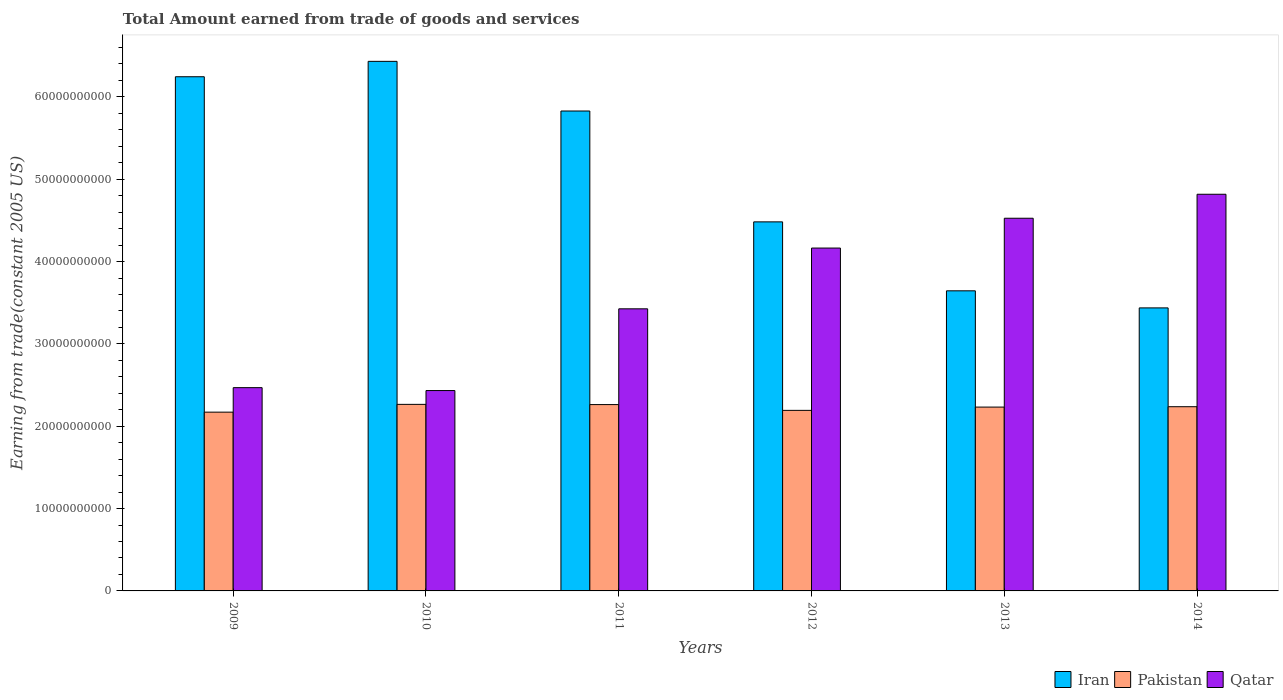How many different coloured bars are there?
Give a very brief answer. 3. Are the number of bars per tick equal to the number of legend labels?
Your response must be concise. Yes. What is the label of the 1st group of bars from the left?
Provide a succinct answer. 2009. In how many cases, is the number of bars for a given year not equal to the number of legend labels?
Offer a terse response. 0. What is the total amount earned by trading goods and services in Pakistan in 2010?
Give a very brief answer. 2.27e+1. Across all years, what is the maximum total amount earned by trading goods and services in Qatar?
Give a very brief answer. 4.82e+1. Across all years, what is the minimum total amount earned by trading goods and services in Iran?
Keep it short and to the point. 3.44e+1. What is the total total amount earned by trading goods and services in Qatar in the graph?
Ensure brevity in your answer.  2.18e+11. What is the difference between the total amount earned by trading goods and services in Qatar in 2012 and that in 2014?
Give a very brief answer. -6.53e+09. What is the difference between the total amount earned by trading goods and services in Iran in 2011 and the total amount earned by trading goods and services in Pakistan in 2009?
Make the answer very short. 3.66e+1. What is the average total amount earned by trading goods and services in Pakistan per year?
Offer a terse response. 2.23e+1. In the year 2014, what is the difference between the total amount earned by trading goods and services in Pakistan and total amount earned by trading goods and services in Qatar?
Provide a short and direct response. -2.58e+1. What is the ratio of the total amount earned by trading goods and services in Qatar in 2009 to that in 2013?
Offer a very short reply. 0.55. Is the difference between the total amount earned by trading goods and services in Pakistan in 2010 and 2012 greater than the difference between the total amount earned by trading goods and services in Qatar in 2010 and 2012?
Your answer should be compact. Yes. What is the difference between the highest and the second highest total amount earned by trading goods and services in Qatar?
Keep it short and to the point. 2.91e+09. What is the difference between the highest and the lowest total amount earned by trading goods and services in Pakistan?
Keep it short and to the point. 9.44e+08. Is the sum of the total amount earned by trading goods and services in Qatar in 2010 and 2014 greater than the maximum total amount earned by trading goods and services in Iran across all years?
Your response must be concise. Yes. What does the 2nd bar from the left in 2010 represents?
Ensure brevity in your answer.  Pakistan. What does the 2nd bar from the right in 2010 represents?
Provide a succinct answer. Pakistan. Are all the bars in the graph horizontal?
Give a very brief answer. No. How many years are there in the graph?
Provide a short and direct response. 6. What is the difference between two consecutive major ticks on the Y-axis?
Ensure brevity in your answer.  1.00e+1. Are the values on the major ticks of Y-axis written in scientific E-notation?
Your answer should be very brief. No. Does the graph contain grids?
Your answer should be very brief. No. How are the legend labels stacked?
Offer a very short reply. Horizontal. What is the title of the graph?
Your answer should be compact. Total Amount earned from trade of goods and services. Does "Panama" appear as one of the legend labels in the graph?
Provide a short and direct response. No. What is the label or title of the Y-axis?
Your answer should be very brief. Earning from trade(constant 2005 US). What is the Earning from trade(constant 2005 US) in Iran in 2009?
Give a very brief answer. 6.24e+1. What is the Earning from trade(constant 2005 US) of Pakistan in 2009?
Provide a short and direct response. 2.17e+1. What is the Earning from trade(constant 2005 US) of Qatar in 2009?
Provide a succinct answer. 2.47e+1. What is the Earning from trade(constant 2005 US) in Iran in 2010?
Your answer should be very brief. 6.43e+1. What is the Earning from trade(constant 2005 US) in Pakistan in 2010?
Give a very brief answer. 2.27e+1. What is the Earning from trade(constant 2005 US) in Qatar in 2010?
Your answer should be very brief. 2.43e+1. What is the Earning from trade(constant 2005 US) in Iran in 2011?
Make the answer very short. 5.83e+1. What is the Earning from trade(constant 2005 US) of Pakistan in 2011?
Your answer should be compact. 2.26e+1. What is the Earning from trade(constant 2005 US) of Qatar in 2011?
Give a very brief answer. 3.43e+1. What is the Earning from trade(constant 2005 US) in Iran in 2012?
Offer a terse response. 4.48e+1. What is the Earning from trade(constant 2005 US) of Pakistan in 2012?
Your answer should be very brief. 2.19e+1. What is the Earning from trade(constant 2005 US) of Qatar in 2012?
Give a very brief answer. 4.16e+1. What is the Earning from trade(constant 2005 US) in Iran in 2013?
Your answer should be very brief. 3.64e+1. What is the Earning from trade(constant 2005 US) in Pakistan in 2013?
Provide a succinct answer. 2.23e+1. What is the Earning from trade(constant 2005 US) of Qatar in 2013?
Give a very brief answer. 4.53e+1. What is the Earning from trade(constant 2005 US) of Iran in 2014?
Your answer should be very brief. 3.44e+1. What is the Earning from trade(constant 2005 US) of Pakistan in 2014?
Offer a terse response. 2.24e+1. What is the Earning from trade(constant 2005 US) in Qatar in 2014?
Your answer should be very brief. 4.82e+1. Across all years, what is the maximum Earning from trade(constant 2005 US) of Iran?
Ensure brevity in your answer.  6.43e+1. Across all years, what is the maximum Earning from trade(constant 2005 US) of Pakistan?
Offer a terse response. 2.27e+1. Across all years, what is the maximum Earning from trade(constant 2005 US) in Qatar?
Provide a short and direct response. 4.82e+1. Across all years, what is the minimum Earning from trade(constant 2005 US) of Iran?
Offer a terse response. 3.44e+1. Across all years, what is the minimum Earning from trade(constant 2005 US) of Pakistan?
Keep it short and to the point. 2.17e+1. Across all years, what is the minimum Earning from trade(constant 2005 US) in Qatar?
Give a very brief answer. 2.43e+1. What is the total Earning from trade(constant 2005 US) in Iran in the graph?
Your answer should be very brief. 3.01e+11. What is the total Earning from trade(constant 2005 US) in Pakistan in the graph?
Ensure brevity in your answer.  1.34e+11. What is the total Earning from trade(constant 2005 US) in Qatar in the graph?
Your answer should be very brief. 2.18e+11. What is the difference between the Earning from trade(constant 2005 US) of Iran in 2009 and that in 2010?
Your answer should be compact. -1.87e+09. What is the difference between the Earning from trade(constant 2005 US) of Pakistan in 2009 and that in 2010?
Make the answer very short. -9.44e+08. What is the difference between the Earning from trade(constant 2005 US) in Qatar in 2009 and that in 2010?
Your answer should be compact. 3.52e+08. What is the difference between the Earning from trade(constant 2005 US) of Iran in 2009 and that in 2011?
Give a very brief answer. 4.16e+09. What is the difference between the Earning from trade(constant 2005 US) of Pakistan in 2009 and that in 2011?
Your answer should be very brief. -9.17e+08. What is the difference between the Earning from trade(constant 2005 US) in Qatar in 2009 and that in 2011?
Offer a very short reply. -9.57e+09. What is the difference between the Earning from trade(constant 2005 US) of Iran in 2009 and that in 2012?
Give a very brief answer. 1.76e+1. What is the difference between the Earning from trade(constant 2005 US) in Pakistan in 2009 and that in 2012?
Provide a succinct answer. -2.16e+08. What is the difference between the Earning from trade(constant 2005 US) of Qatar in 2009 and that in 2012?
Keep it short and to the point. -1.70e+1. What is the difference between the Earning from trade(constant 2005 US) of Iran in 2009 and that in 2013?
Ensure brevity in your answer.  2.60e+1. What is the difference between the Earning from trade(constant 2005 US) of Pakistan in 2009 and that in 2013?
Offer a very short reply. -6.13e+08. What is the difference between the Earning from trade(constant 2005 US) of Qatar in 2009 and that in 2013?
Provide a succinct answer. -2.06e+1. What is the difference between the Earning from trade(constant 2005 US) of Iran in 2009 and that in 2014?
Offer a very short reply. 2.81e+1. What is the difference between the Earning from trade(constant 2005 US) of Pakistan in 2009 and that in 2014?
Offer a terse response. -6.59e+08. What is the difference between the Earning from trade(constant 2005 US) in Qatar in 2009 and that in 2014?
Your response must be concise. -2.35e+1. What is the difference between the Earning from trade(constant 2005 US) of Iran in 2010 and that in 2011?
Your response must be concise. 6.03e+09. What is the difference between the Earning from trade(constant 2005 US) of Pakistan in 2010 and that in 2011?
Offer a very short reply. 2.70e+07. What is the difference between the Earning from trade(constant 2005 US) of Qatar in 2010 and that in 2011?
Your answer should be compact. -9.93e+09. What is the difference between the Earning from trade(constant 2005 US) in Iran in 2010 and that in 2012?
Give a very brief answer. 1.95e+1. What is the difference between the Earning from trade(constant 2005 US) in Pakistan in 2010 and that in 2012?
Make the answer very short. 7.28e+08. What is the difference between the Earning from trade(constant 2005 US) of Qatar in 2010 and that in 2012?
Provide a succinct answer. -1.73e+1. What is the difference between the Earning from trade(constant 2005 US) in Iran in 2010 and that in 2013?
Ensure brevity in your answer.  2.79e+1. What is the difference between the Earning from trade(constant 2005 US) of Pakistan in 2010 and that in 2013?
Give a very brief answer. 3.31e+08. What is the difference between the Earning from trade(constant 2005 US) in Qatar in 2010 and that in 2013?
Keep it short and to the point. -2.09e+1. What is the difference between the Earning from trade(constant 2005 US) of Iran in 2010 and that in 2014?
Make the answer very short. 2.99e+1. What is the difference between the Earning from trade(constant 2005 US) in Pakistan in 2010 and that in 2014?
Provide a short and direct response. 2.85e+08. What is the difference between the Earning from trade(constant 2005 US) of Qatar in 2010 and that in 2014?
Give a very brief answer. -2.38e+1. What is the difference between the Earning from trade(constant 2005 US) of Iran in 2011 and that in 2012?
Offer a terse response. 1.35e+1. What is the difference between the Earning from trade(constant 2005 US) of Pakistan in 2011 and that in 2012?
Provide a short and direct response. 7.01e+08. What is the difference between the Earning from trade(constant 2005 US) in Qatar in 2011 and that in 2012?
Keep it short and to the point. -7.38e+09. What is the difference between the Earning from trade(constant 2005 US) of Iran in 2011 and that in 2013?
Ensure brevity in your answer.  2.18e+1. What is the difference between the Earning from trade(constant 2005 US) in Pakistan in 2011 and that in 2013?
Make the answer very short. 3.04e+08. What is the difference between the Earning from trade(constant 2005 US) in Qatar in 2011 and that in 2013?
Offer a very short reply. -1.10e+1. What is the difference between the Earning from trade(constant 2005 US) of Iran in 2011 and that in 2014?
Offer a terse response. 2.39e+1. What is the difference between the Earning from trade(constant 2005 US) of Pakistan in 2011 and that in 2014?
Provide a succinct answer. 2.58e+08. What is the difference between the Earning from trade(constant 2005 US) of Qatar in 2011 and that in 2014?
Your answer should be very brief. -1.39e+1. What is the difference between the Earning from trade(constant 2005 US) in Iran in 2012 and that in 2013?
Provide a succinct answer. 8.37e+09. What is the difference between the Earning from trade(constant 2005 US) of Pakistan in 2012 and that in 2013?
Offer a very short reply. -3.97e+08. What is the difference between the Earning from trade(constant 2005 US) in Qatar in 2012 and that in 2013?
Offer a terse response. -3.62e+09. What is the difference between the Earning from trade(constant 2005 US) in Iran in 2012 and that in 2014?
Offer a terse response. 1.04e+1. What is the difference between the Earning from trade(constant 2005 US) in Pakistan in 2012 and that in 2014?
Make the answer very short. -4.43e+08. What is the difference between the Earning from trade(constant 2005 US) in Qatar in 2012 and that in 2014?
Offer a very short reply. -6.53e+09. What is the difference between the Earning from trade(constant 2005 US) in Iran in 2013 and that in 2014?
Ensure brevity in your answer.  2.07e+09. What is the difference between the Earning from trade(constant 2005 US) of Pakistan in 2013 and that in 2014?
Provide a succinct answer. -4.60e+07. What is the difference between the Earning from trade(constant 2005 US) in Qatar in 2013 and that in 2014?
Offer a terse response. -2.91e+09. What is the difference between the Earning from trade(constant 2005 US) of Iran in 2009 and the Earning from trade(constant 2005 US) of Pakistan in 2010?
Your answer should be compact. 3.98e+1. What is the difference between the Earning from trade(constant 2005 US) of Iran in 2009 and the Earning from trade(constant 2005 US) of Qatar in 2010?
Offer a terse response. 3.81e+1. What is the difference between the Earning from trade(constant 2005 US) of Pakistan in 2009 and the Earning from trade(constant 2005 US) of Qatar in 2010?
Provide a succinct answer. -2.62e+09. What is the difference between the Earning from trade(constant 2005 US) of Iran in 2009 and the Earning from trade(constant 2005 US) of Pakistan in 2011?
Your answer should be compact. 3.98e+1. What is the difference between the Earning from trade(constant 2005 US) of Iran in 2009 and the Earning from trade(constant 2005 US) of Qatar in 2011?
Give a very brief answer. 2.82e+1. What is the difference between the Earning from trade(constant 2005 US) of Pakistan in 2009 and the Earning from trade(constant 2005 US) of Qatar in 2011?
Give a very brief answer. -1.25e+1. What is the difference between the Earning from trade(constant 2005 US) of Iran in 2009 and the Earning from trade(constant 2005 US) of Pakistan in 2012?
Your answer should be compact. 4.05e+1. What is the difference between the Earning from trade(constant 2005 US) of Iran in 2009 and the Earning from trade(constant 2005 US) of Qatar in 2012?
Ensure brevity in your answer.  2.08e+1. What is the difference between the Earning from trade(constant 2005 US) of Pakistan in 2009 and the Earning from trade(constant 2005 US) of Qatar in 2012?
Provide a succinct answer. -1.99e+1. What is the difference between the Earning from trade(constant 2005 US) of Iran in 2009 and the Earning from trade(constant 2005 US) of Pakistan in 2013?
Keep it short and to the point. 4.01e+1. What is the difference between the Earning from trade(constant 2005 US) of Iran in 2009 and the Earning from trade(constant 2005 US) of Qatar in 2013?
Ensure brevity in your answer.  1.72e+1. What is the difference between the Earning from trade(constant 2005 US) in Pakistan in 2009 and the Earning from trade(constant 2005 US) in Qatar in 2013?
Provide a short and direct response. -2.36e+1. What is the difference between the Earning from trade(constant 2005 US) in Iran in 2009 and the Earning from trade(constant 2005 US) in Pakistan in 2014?
Your answer should be very brief. 4.01e+1. What is the difference between the Earning from trade(constant 2005 US) in Iran in 2009 and the Earning from trade(constant 2005 US) in Qatar in 2014?
Give a very brief answer. 1.43e+1. What is the difference between the Earning from trade(constant 2005 US) of Pakistan in 2009 and the Earning from trade(constant 2005 US) of Qatar in 2014?
Your answer should be compact. -2.65e+1. What is the difference between the Earning from trade(constant 2005 US) of Iran in 2010 and the Earning from trade(constant 2005 US) of Pakistan in 2011?
Provide a short and direct response. 4.17e+1. What is the difference between the Earning from trade(constant 2005 US) of Iran in 2010 and the Earning from trade(constant 2005 US) of Qatar in 2011?
Make the answer very short. 3.01e+1. What is the difference between the Earning from trade(constant 2005 US) in Pakistan in 2010 and the Earning from trade(constant 2005 US) in Qatar in 2011?
Give a very brief answer. -1.16e+1. What is the difference between the Earning from trade(constant 2005 US) in Iran in 2010 and the Earning from trade(constant 2005 US) in Pakistan in 2012?
Give a very brief answer. 4.24e+1. What is the difference between the Earning from trade(constant 2005 US) of Iran in 2010 and the Earning from trade(constant 2005 US) of Qatar in 2012?
Your answer should be very brief. 2.27e+1. What is the difference between the Earning from trade(constant 2005 US) in Pakistan in 2010 and the Earning from trade(constant 2005 US) in Qatar in 2012?
Provide a succinct answer. -1.90e+1. What is the difference between the Earning from trade(constant 2005 US) in Iran in 2010 and the Earning from trade(constant 2005 US) in Pakistan in 2013?
Your answer should be compact. 4.20e+1. What is the difference between the Earning from trade(constant 2005 US) of Iran in 2010 and the Earning from trade(constant 2005 US) of Qatar in 2013?
Provide a succinct answer. 1.91e+1. What is the difference between the Earning from trade(constant 2005 US) of Pakistan in 2010 and the Earning from trade(constant 2005 US) of Qatar in 2013?
Offer a very short reply. -2.26e+1. What is the difference between the Earning from trade(constant 2005 US) in Iran in 2010 and the Earning from trade(constant 2005 US) in Pakistan in 2014?
Give a very brief answer. 4.19e+1. What is the difference between the Earning from trade(constant 2005 US) of Iran in 2010 and the Earning from trade(constant 2005 US) of Qatar in 2014?
Your answer should be compact. 1.61e+1. What is the difference between the Earning from trade(constant 2005 US) of Pakistan in 2010 and the Earning from trade(constant 2005 US) of Qatar in 2014?
Provide a short and direct response. -2.55e+1. What is the difference between the Earning from trade(constant 2005 US) in Iran in 2011 and the Earning from trade(constant 2005 US) in Pakistan in 2012?
Provide a succinct answer. 3.64e+1. What is the difference between the Earning from trade(constant 2005 US) of Iran in 2011 and the Earning from trade(constant 2005 US) of Qatar in 2012?
Give a very brief answer. 1.66e+1. What is the difference between the Earning from trade(constant 2005 US) of Pakistan in 2011 and the Earning from trade(constant 2005 US) of Qatar in 2012?
Give a very brief answer. -1.90e+1. What is the difference between the Earning from trade(constant 2005 US) in Iran in 2011 and the Earning from trade(constant 2005 US) in Pakistan in 2013?
Your answer should be compact. 3.60e+1. What is the difference between the Earning from trade(constant 2005 US) of Iran in 2011 and the Earning from trade(constant 2005 US) of Qatar in 2013?
Make the answer very short. 1.30e+1. What is the difference between the Earning from trade(constant 2005 US) of Pakistan in 2011 and the Earning from trade(constant 2005 US) of Qatar in 2013?
Your response must be concise. -2.26e+1. What is the difference between the Earning from trade(constant 2005 US) in Iran in 2011 and the Earning from trade(constant 2005 US) in Pakistan in 2014?
Your answer should be very brief. 3.59e+1. What is the difference between the Earning from trade(constant 2005 US) in Iran in 2011 and the Earning from trade(constant 2005 US) in Qatar in 2014?
Give a very brief answer. 1.01e+1. What is the difference between the Earning from trade(constant 2005 US) of Pakistan in 2011 and the Earning from trade(constant 2005 US) of Qatar in 2014?
Your answer should be compact. -2.55e+1. What is the difference between the Earning from trade(constant 2005 US) of Iran in 2012 and the Earning from trade(constant 2005 US) of Pakistan in 2013?
Provide a succinct answer. 2.25e+1. What is the difference between the Earning from trade(constant 2005 US) of Iran in 2012 and the Earning from trade(constant 2005 US) of Qatar in 2013?
Provide a succinct answer. -4.41e+08. What is the difference between the Earning from trade(constant 2005 US) in Pakistan in 2012 and the Earning from trade(constant 2005 US) in Qatar in 2013?
Give a very brief answer. -2.33e+1. What is the difference between the Earning from trade(constant 2005 US) in Iran in 2012 and the Earning from trade(constant 2005 US) in Pakistan in 2014?
Provide a succinct answer. 2.25e+1. What is the difference between the Earning from trade(constant 2005 US) of Iran in 2012 and the Earning from trade(constant 2005 US) of Qatar in 2014?
Offer a very short reply. -3.35e+09. What is the difference between the Earning from trade(constant 2005 US) in Pakistan in 2012 and the Earning from trade(constant 2005 US) in Qatar in 2014?
Offer a very short reply. -2.62e+1. What is the difference between the Earning from trade(constant 2005 US) in Iran in 2013 and the Earning from trade(constant 2005 US) in Pakistan in 2014?
Offer a terse response. 1.41e+1. What is the difference between the Earning from trade(constant 2005 US) in Iran in 2013 and the Earning from trade(constant 2005 US) in Qatar in 2014?
Make the answer very short. -1.17e+1. What is the difference between the Earning from trade(constant 2005 US) of Pakistan in 2013 and the Earning from trade(constant 2005 US) of Qatar in 2014?
Provide a short and direct response. -2.58e+1. What is the average Earning from trade(constant 2005 US) of Iran per year?
Offer a very short reply. 5.01e+1. What is the average Earning from trade(constant 2005 US) in Pakistan per year?
Provide a short and direct response. 2.23e+1. What is the average Earning from trade(constant 2005 US) of Qatar per year?
Give a very brief answer. 3.64e+1. In the year 2009, what is the difference between the Earning from trade(constant 2005 US) in Iran and Earning from trade(constant 2005 US) in Pakistan?
Provide a short and direct response. 4.07e+1. In the year 2009, what is the difference between the Earning from trade(constant 2005 US) in Iran and Earning from trade(constant 2005 US) in Qatar?
Your answer should be compact. 3.78e+1. In the year 2009, what is the difference between the Earning from trade(constant 2005 US) in Pakistan and Earning from trade(constant 2005 US) in Qatar?
Give a very brief answer. -2.97e+09. In the year 2010, what is the difference between the Earning from trade(constant 2005 US) of Iran and Earning from trade(constant 2005 US) of Pakistan?
Provide a short and direct response. 4.17e+1. In the year 2010, what is the difference between the Earning from trade(constant 2005 US) in Iran and Earning from trade(constant 2005 US) in Qatar?
Offer a terse response. 4.00e+1. In the year 2010, what is the difference between the Earning from trade(constant 2005 US) in Pakistan and Earning from trade(constant 2005 US) in Qatar?
Your answer should be very brief. -1.68e+09. In the year 2011, what is the difference between the Earning from trade(constant 2005 US) in Iran and Earning from trade(constant 2005 US) in Pakistan?
Your answer should be compact. 3.57e+1. In the year 2011, what is the difference between the Earning from trade(constant 2005 US) in Iran and Earning from trade(constant 2005 US) in Qatar?
Offer a very short reply. 2.40e+1. In the year 2011, what is the difference between the Earning from trade(constant 2005 US) in Pakistan and Earning from trade(constant 2005 US) in Qatar?
Provide a succinct answer. -1.16e+1. In the year 2012, what is the difference between the Earning from trade(constant 2005 US) in Iran and Earning from trade(constant 2005 US) in Pakistan?
Keep it short and to the point. 2.29e+1. In the year 2012, what is the difference between the Earning from trade(constant 2005 US) of Iran and Earning from trade(constant 2005 US) of Qatar?
Offer a very short reply. 3.18e+09. In the year 2012, what is the difference between the Earning from trade(constant 2005 US) in Pakistan and Earning from trade(constant 2005 US) in Qatar?
Offer a very short reply. -1.97e+1. In the year 2013, what is the difference between the Earning from trade(constant 2005 US) in Iran and Earning from trade(constant 2005 US) in Pakistan?
Your answer should be compact. 1.41e+1. In the year 2013, what is the difference between the Earning from trade(constant 2005 US) in Iran and Earning from trade(constant 2005 US) in Qatar?
Offer a very short reply. -8.82e+09. In the year 2013, what is the difference between the Earning from trade(constant 2005 US) of Pakistan and Earning from trade(constant 2005 US) of Qatar?
Offer a terse response. -2.29e+1. In the year 2014, what is the difference between the Earning from trade(constant 2005 US) of Iran and Earning from trade(constant 2005 US) of Pakistan?
Your answer should be very brief. 1.20e+1. In the year 2014, what is the difference between the Earning from trade(constant 2005 US) of Iran and Earning from trade(constant 2005 US) of Qatar?
Provide a succinct answer. -1.38e+1. In the year 2014, what is the difference between the Earning from trade(constant 2005 US) in Pakistan and Earning from trade(constant 2005 US) in Qatar?
Your response must be concise. -2.58e+1. What is the ratio of the Earning from trade(constant 2005 US) in Iran in 2009 to that in 2010?
Give a very brief answer. 0.97. What is the ratio of the Earning from trade(constant 2005 US) of Qatar in 2009 to that in 2010?
Ensure brevity in your answer.  1.01. What is the ratio of the Earning from trade(constant 2005 US) of Iran in 2009 to that in 2011?
Your answer should be very brief. 1.07. What is the ratio of the Earning from trade(constant 2005 US) in Pakistan in 2009 to that in 2011?
Your answer should be compact. 0.96. What is the ratio of the Earning from trade(constant 2005 US) in Qatar in 2009 to that in 2011?
Make the answer very short. 0.72. What is the ratio of the Earning from trade(constant 2005 US) of Iran in 2009 to that in 2012?
Your answer should be very brief. 1.39. What is the ratio of the Earning from trade(constant 2005 US) in Pakistan in 2009 to that in 2012?
Make the answer very short. 0.99. What is the ratio of the Earning from trade(constant 2005 US) in Qatar in 2009 to that in 2012?
Provide a succinct answer. 0.59. What is the ratio of the Earning from trade(constant 2005 US) of Iran in 2009 to that in 2013?
Your response must be concise. 1.71. What is the ratio of the Earning from trade(constant 2005 US) of Pakistan in 2009 to that in 2013?
Give a very brief answer. 0.97. What is the ratio of the Earning from trade(constant 2005 US) of Qatar in 2009 to that in 2013?
Offer a very short reply. 0.55. What is the ratio of the Earning from trade(constant 2005 US) of Iran in 2009 to that in 2014?
Keep it short and to the point. 1.82. What is the ratio of the Earning from trade(constant 2005 US) of Pakistan in 2009 to that in 2014?
Offer a terse response. 0.97. What is the ratio of the Earning from trade(constant 2005 US) of Qatar in 2009 to that in 2014?
Offer a terse response. 0.51. What is the ratio of the Earning from trade(constant 2005 US) in Iran in 2010 to that in 2011?
Provide a succinct answer. 1.1. What is the ratio of the Earning from trade(constant 2005 US) of Qatar in 2010 to that in 2011?
Your response must be concise. 0.71. What is the ratio of the Earning from trade(constant 2005 US) of Iran in 2010 to that in 2012?
Your answer should be compact. 1.43. What is the ratio of the Earning from trade(constant 2005 US) of Pakistan in 2010 to that in 2012?
Give a very brief answer. 1.03. What is the ratio of the Earning from trade(constant 2005 US) of Qatar in 2010 to that in 2012?
Ensure brevity in your answer.  0.58. What is the ratio of the Earning from trade(constant 2005 US) of Iran in 2010 to that in 2013?
Your answer should be very brief. 1.76. What is the ratio of the Earning from trade(constant 2005 US) in Pakistan in 2010 to that in 2013?
Provide a short and direct response. 1.01. What is the ratio of the Earning from trade(constant 2005 US) in Qatar in 2010 to that in 2013?
Ensure brevity in your answer.  0.54. What is the ratio of the Earning from trade(constant 2005 US) in Iran in 2010 to that in 2014?
Offer a terse response. 1.87. What is the ratio of the Earning from trade(constant 2005 US) of Pakistan in 2010 to that in 2014?
Ensure brevity in your answer.  1.01. What is the ratio of the Earning from trade(constant 2005 US) of Qatar in 2010 to that in 2014?
Your answer should be very brief. 0.51. What is the ratio of the Earning from trade(constant 2005 US) of Iran in 2011 to that in 2012?
Provide a succinct answer. 1.3. What is the ratio of the Earning from trade(constant 2005 US) of Pakistan in 2011 to that in 2012?
Keep it short and to the point. 1.03. What is the ratio of the Earning from trade(constant 2005 US) in Qatar in 2011 to that in 2012?
Make the answer very short. 0.82. What is the ratio of the Earning from trade(constant 2005 US) in Iran in 2011 to that in 2013?
Provide a succinct answer. 1.6. What is the ratio of the Earning from trade(constant 2005 US) in Pakistan in 2011 to that in 2013?
Your answer should be compact. 1.01. What is the ratio of the Earning from trade(constant 2005 US) of Qatar in 2011 to that in 2013?
Your response must be concise. 0.76. What is the ratio of the Earning from trade(constant 2005 US) in Iran in 2011 to that in 2014?
Your response must be concise. 1.7. What is the ratio of the Earning from trade(constant 2005 US) in Pakistan in 2011 to that in 2014?
Offer a terse response. 1.01. What is the ratio of the Earning from trade(constant 2005 US) in Qatar in 2011 to that in 2014?
Offer a very short reply. 0.71. What is the ratio of the Earning from trade(constant 2005 US) of Iran in 2012 to that in 2013?
Provide a succinct answer. 1.23. What is the ratio of the Earning from trade(constant 2005 US) of Pakistan in 2012 to that in 2013?
Your response must be concise. 0.98. What is the ratio of the Earning from trade(constant 2005 US) in Qatar in 2012 to that in 2013?
Provide a succinct answer. 0.92. What is the ratio of the Earning from trade(constant 2005 US) in Iran in 2012 to that in 2014?
Your answer should be compact. 1.3. What is the ratio of the Earning from trade(constant 2005 US) of Pakistan in 2012 to that in 2014?
Give a very brief answer. 0.98. What is the ratio of the Earning from trade(constant 2005 US) in Qatar in 2012 to that in 2014?
Ensure brevity in your answer.  0.86. What is the ratio of the Earning from trade(constant 2005 US) in Iran in 2013 to that in 2014?
Ensure brevity in your answer.  1.06. What is the ratio of the Earning from trade(constant 2005 US) of Qatar in 2013 to that in 2014?
Make the answer very short. 0.94. What is the difference between the highest and the second highest Earning from trade(constant 2005 US) of Iran?
Your answer should be compact. 1.87e+09. What is the difference between the highest and the second highest Earning from trade(constant 2005 US) in Pakistan?
Your answer should be very brief. 2.70e+07. What is the difference between the highest and the second highest Earning from trade(constant 2005 US) of Qatar?
Your answer should be compact. 2.91e+09. What is the difference between the highest and the lowest Earning from trade(constant 2005 US) of Iran?
Your response must be concise. 2.99e+1. What is the difference between the highest and the lowest Earning from trade(constant 2005 US) of Pakistan?
Offer a very short reply. 9.44e+08. What is the difference between the highest and the lowest Earning from trade(constant 2005 US) of Qatar?
Offer a very short reply. 2.38e+1. 